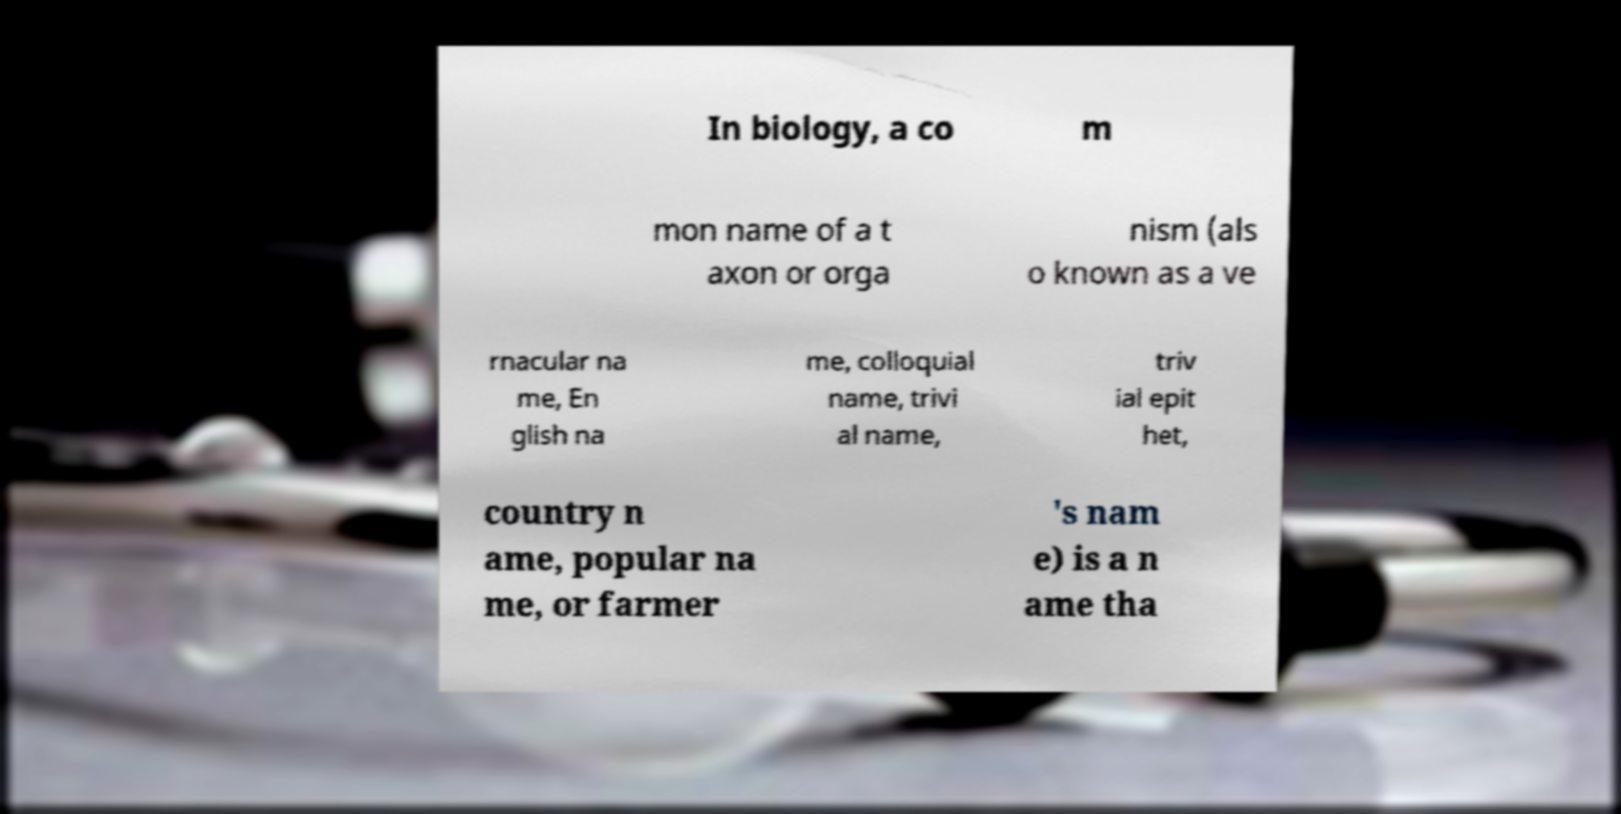Please identify and transcribe the text found in this image. In biology, a co m mon name of a t axon or orga nism (als o known as a ve rnacular na me, En glish na me, colloquial name, trivi al name, triv ial epit het, country n ame, popular na me, or farmer 's nam e) is a n ame tha 